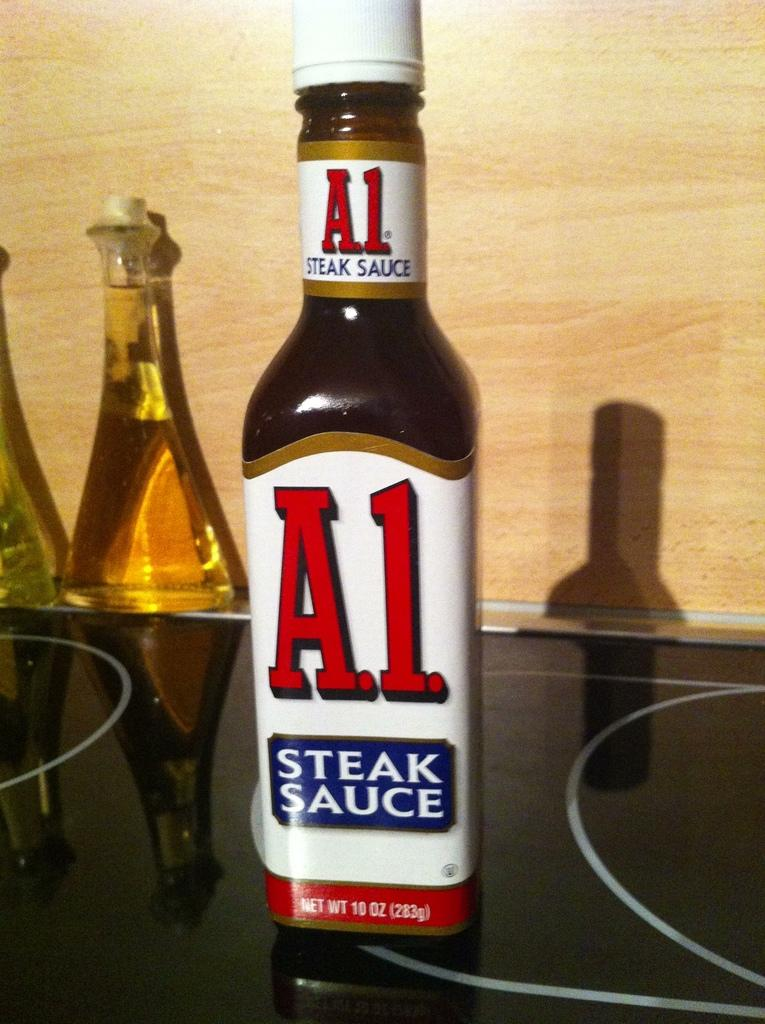<image>
Summarize the visual content of the image. A bottle of A.1. steak sauce is sitting on top of a stove. 